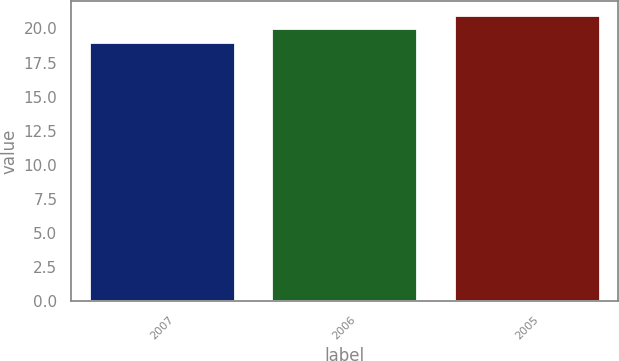Convert chart. <chart><loc_0><loc_0><loc_500><loc_500><bar_chart><fcel>2007<fcel>2006<fcel>2005<nl><fcel>19<fcel>20<fcel>21<nl></chart> 